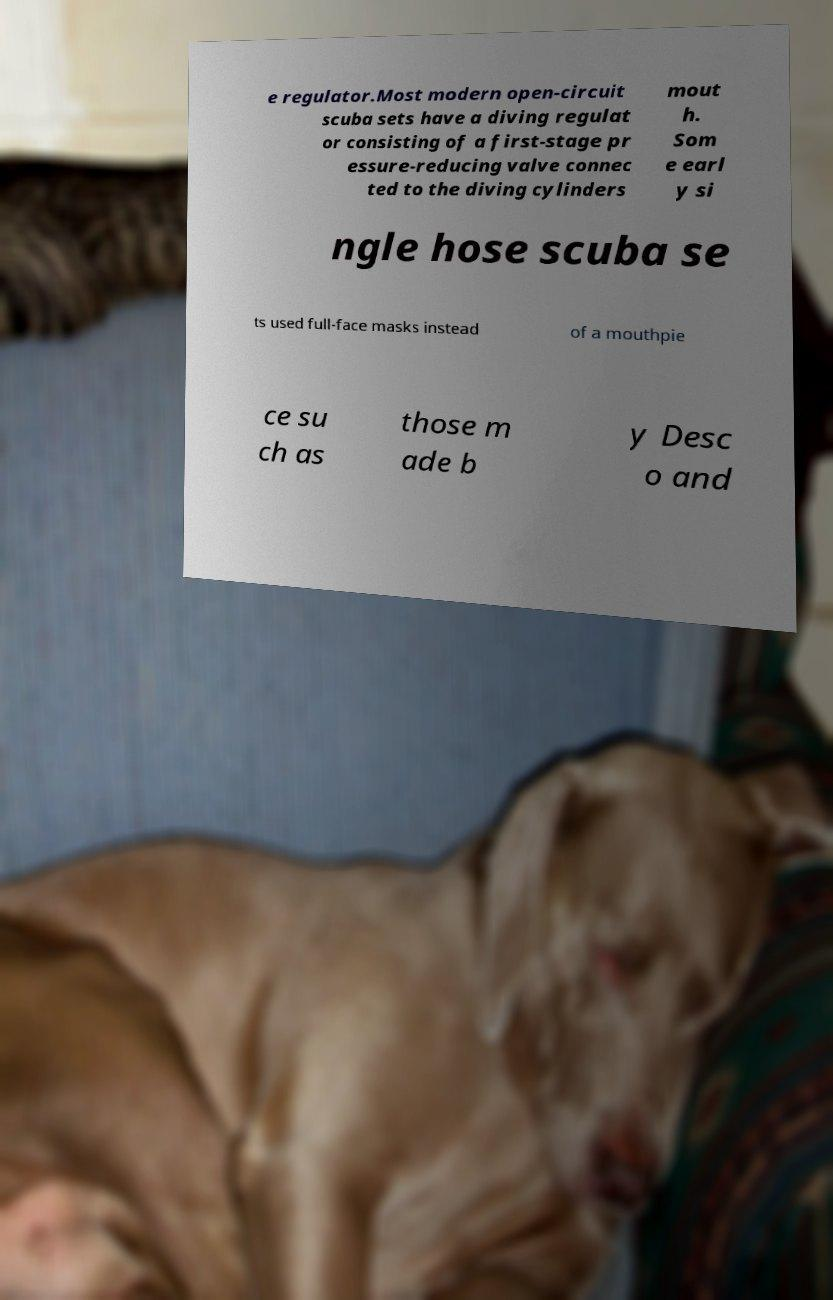Please identify and transcribe the text found in this image. e regulator.Most modern open-circuit scuba sets have a diving regulat or consisting of a first-stage pr essure-reducing valve connec ted to the diving cylinders mout h. Som e earl y si ngle hose scuba se ts used full-face masks instead of a mouthpie ce su ch as those m ade b y Desc o and 